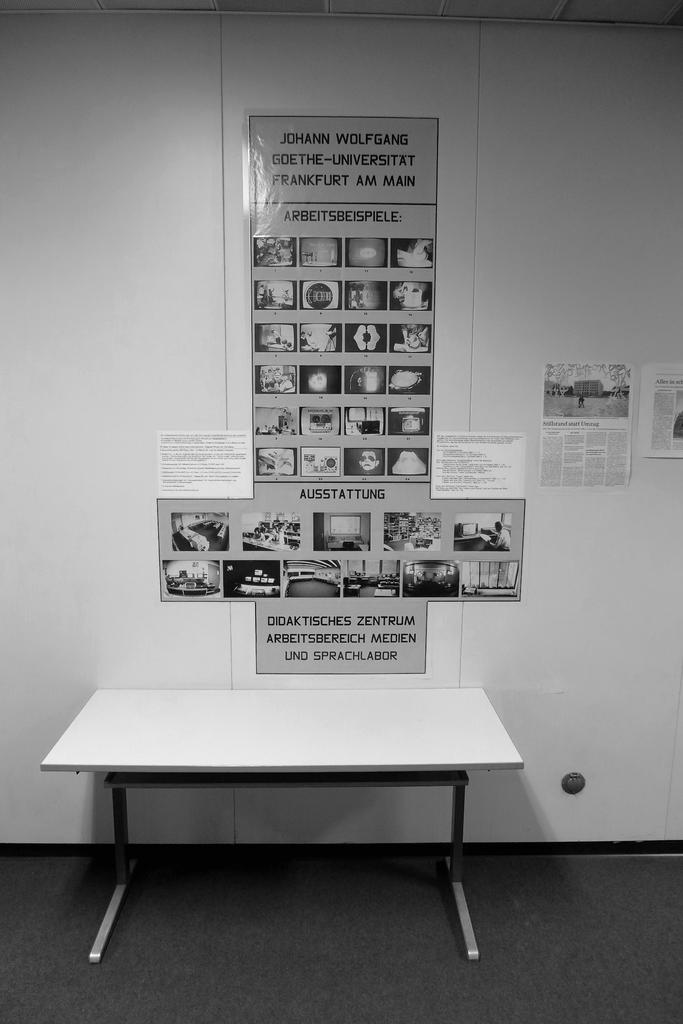What type of furniture is present in the image? There is a white table in the image. What can be seen on the wall in the image? There are papers attached to the wall in the image. What color scheme is used in the image? The image is black and white in color. What type of dinner is being served on the white table in the image? There is no dinner present in the image; it only shows a white table and papers attached to a wall. Can you see a heart-shaped object in the image? There is no heart-shaped object visible in the image. 